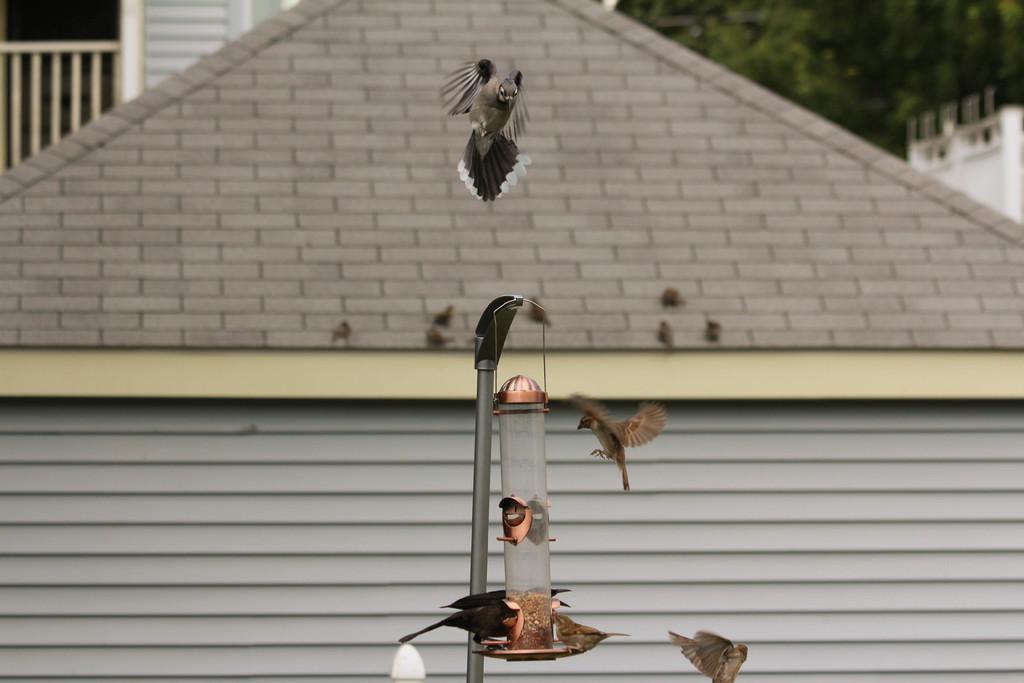Describe this image in one or two sentences. This image is taken outdoors. In the background there are a few trees and there is a building. There is a railing and a window. There is a wall and there are a few birds on the roof. In the middle of the image there is a bird feeder with food and their and there are a few birds flying in the air. 